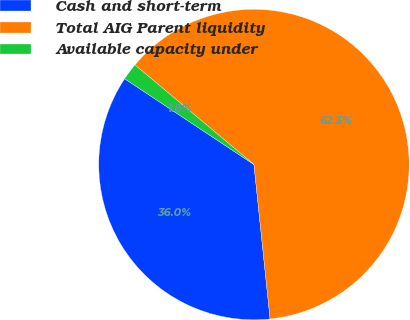Convert chart. <chart><loc_0><loc_0><loc_500><loc_500><pie_chart><fcel>Cash and short-term<fcel>Total AIG Parent liquidity<fcel>Available capacity under<nl><fcel>35.98%<fcel>62.25%<fcel>1.77%<nl></chart> 